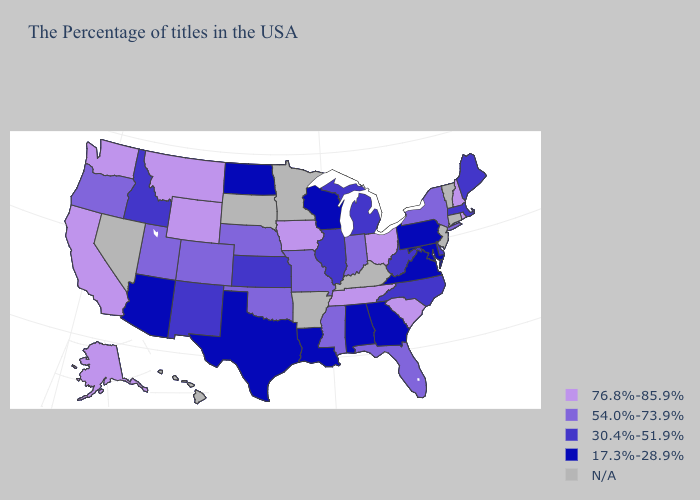Name the states that have a value in the range 17.3%-28.9%?
Give a very brief answer. Maryland, Pennsylvania, Virginia, Georgia, Alabama, Wisconsin, Louisiana, Texas, North Dakota, Arizona. What is the highest value in the Northeast ?
Keep it brief. 76.8%-85.9%. Name the states that have a value in the range 76.8%-85.9%?
Short answer required. Rhode Island, New Hampshire, South Carolina, Ohio, Tennessee, Iowa, Wyoming, Montana, California, Washington, Alaska. Does the first symbol in the legend represent the smallest category?
Be succinct. No. Which states have the lowest value in the Northeast?
Concise answer only. Pennsylvania. Does Missouri have the lowest value in the MidWest?
Give a very brief answer. No. Which states hav the highest value in the South?
Be succinct. South Carolina, Tennessee. What is the value of Alaska?
Keep it brief. 76.8%-85.9%. How many symbols are there in the legend?
Short answer required. 5. Does Texas have the lowest value in the USA?
Write a very short answer. Yes. Among the states that border Iowa , does Nebraska have the highest value?
Be succinct. Yes. Is the legend a continuous bar?
Be succinct. No. Among the states that border New Hampshire , which have the lowest value?
Keep it brief. Maine, Massachusetts. Does Maine have the lowest value in the USA?
Quick response, please. No. 